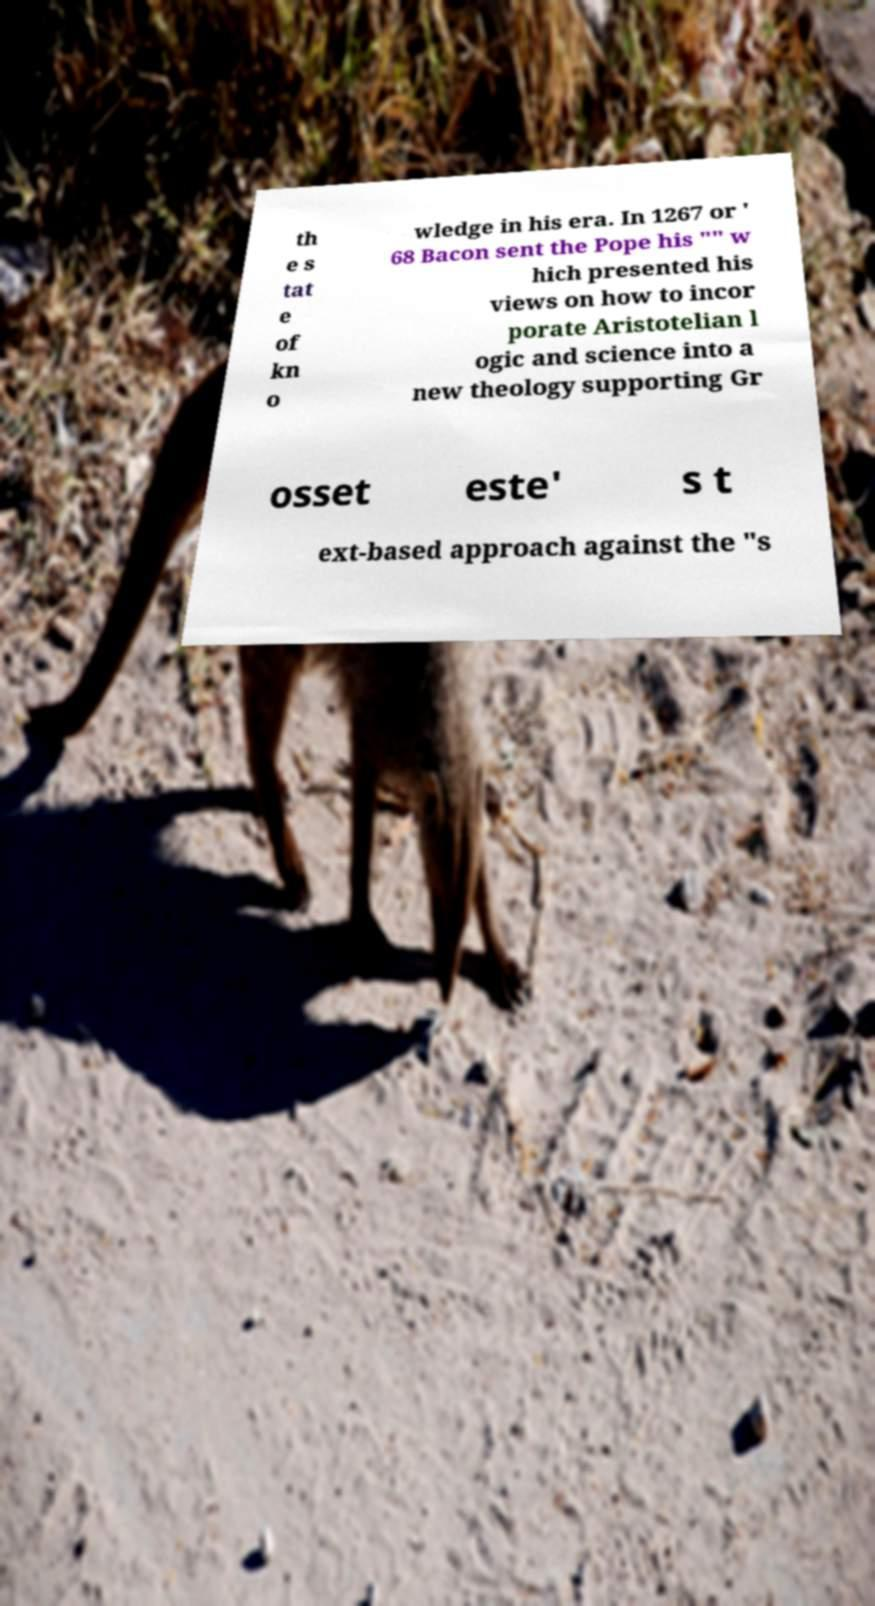There's text embedded in this image that I need extracted. Can you transcribe it verbatim? th e s tat e of kn o wledge in his era. In 1267 or ' 68 Bacon sent the Pope his "" w hich presented his views on how to incor porate Aristotelian l ogic and science into a new theology supporting Gr osset este' s t ext-based approach against the "s 